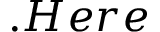<formula> <loc_0><loc_0><loc_500><loc_500>. H e r e</formula> 